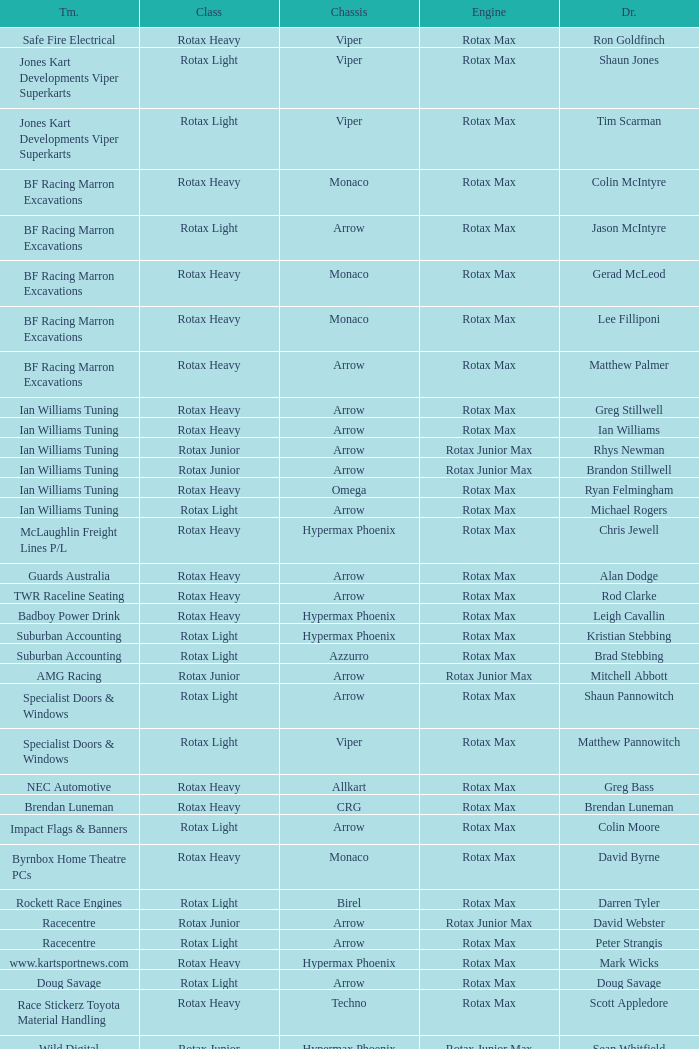Which team does Colin Moore drive for? Impact Flags & Banners. 